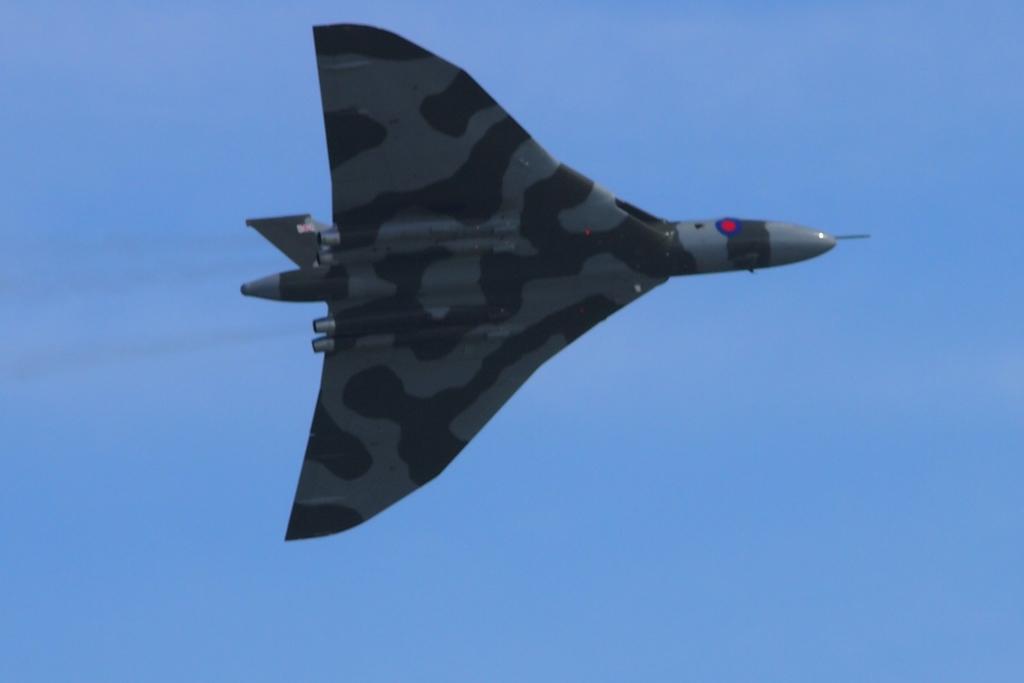Describe this image in one or two sentences. In this picture we can see an aircraft is flying. Behind the aircraft, there is the sky. 